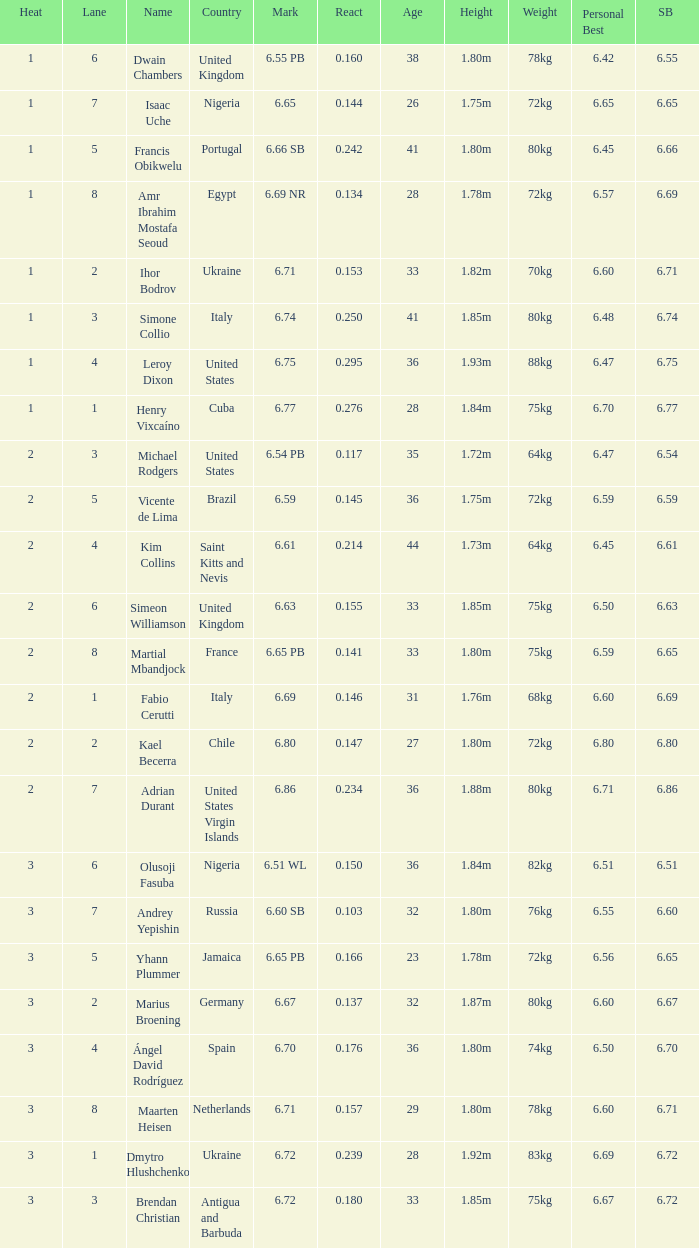What is the lowest Lane, when Country is France, and when React is less than 0.14100000000000001? 8.0. 